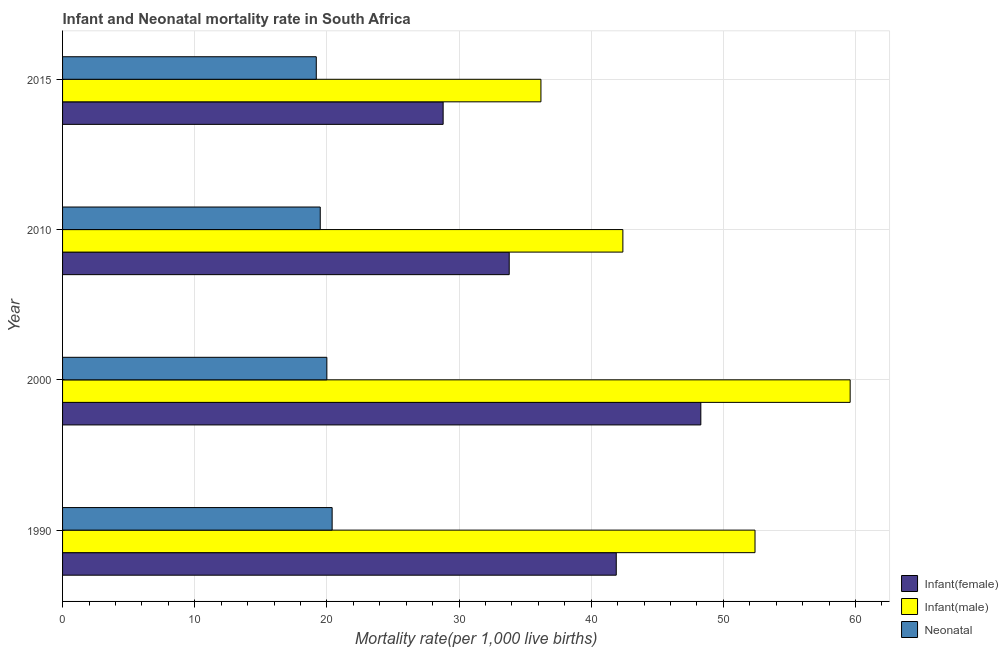How many different coloured bars are there?
Provide a succinct answer. 3. How many groups of bars are there?
Offer a very short reply. 4. Are the number of bars per tick equal to the number of legend labels?
Your answer should be very brief. Yes. How many bars are there on the 1st tick from the bottom?
Offer a very short reply. 3. In how many cases, is the number of bars for a given year not equal to the number of legend labels?
Keep it short and to the point. 0. What is the infant mortality rate(male) in 2015?
Your answer should be very brief. 36.2. Across all years, what is the maximum infant mortality rate(male)?
Offer a terse response. 59.6. Across all years, what is the minimum infant mortality rate(male)?
Offer a terse response. 36.2. In which year was the infant mortality rate(male) maximum?
Offer a very short reply. 2000. In which year was the infant mortality rate(male) minimum?
Your answer should be compact. 2015. What is the total neonatal mortality rate in the graph?
Offer a terse response. 79.1. What is the average infant mortality rate(male) per year?
Make the answer very short. 47.65. In the year 2000, what is the difference between the infant mortality rate(female) and neonatal mortality rate?
Your answer should be very brief. 28.3. In how many years, is the neonatal mortality rate greater than 28 ?
Your response must be concise. 0. What is the ratio of the infant mortality rate(female) in 2000 to that in 2010?
Ensure brevity in your answer.  1.43. What is the difference between the highest and the second highest infant mortality rate(male)?
Provide a short and direct response. 7.2. What is the difference between the highest and the lowest neonatal mortality rate?
Provide a short and direct response. 1.2. In how many years, is the neonatal mortality rate greater than the average neonatal mortality rate taken over all years?
Offer a terse response. 2. What does the 3rd bar from the top in 2015 represents?
Give a very brief answer. Infant(female). What does the 3rd bar from the bottom in 2015 represents?
Provide a short and direct response. Neonatal . How many years are there in the graph?
Your answer should be compact. 4. Are the values on the major ticks of X-axis written in scientific E-notation?
Offer a very short reply. No. Does the graph contain any zero values?
Keep it short and to the point. No. Does the graph contain grids?
Your response must be concise. Yes. Where does the legend appear in the graph?
Make the answer very short. Bottom right. What is the title of the graph?
Ensure brevity in your answer.  Infant and Neonatal mortality rate in South Africa. Does "Tertiary education" appear as one of the legend labels in the graph?
Your answer should be very brief. No. What is the label or title of the X-axis?
Your answer should be very brief. Mortality rate(per 1,0 live births). What is the Mortality rate(per 1,000 live births) in Infant(female) in 1990?
Keep it short and to the point. 41.9. What is the Mortality rate(per 1,000 live births) in Infant(male) in 1990?
Give a very brief answer. 52.4. What is the Mortality rate(per 1,000 live births) in Neonatal  in 1990?
Your answer should be very brief. 20.4. What is the Mortality rate(per 1,000 live births) of Infant(female) in 2000?
Your answer should be compact. 48.3. What is the Mortality rate(per 1,000 live births) of Infant(male) in 2000?
Your response must be concise. 59.6. What is the Mortality rate(per 1,000 live births) of Neonatal  in 2000?
Make the answer very short. 20. What is the Mortality rate(per 1,000 live births) in Infant(female) in 2010?
Provide a succinct answer. 33.8. What is the Mortality rate(per 1,000 live births) of Infant(male) in 2010?
Offer a terse response. 42.4. What is the Mortality rate(per 1,000 live births) of Neonatal  in 2010?
Keep it short and to the point. 19.5. What is the Mortality rate(per 1,000 live births) in Infant(female) in 2015?
Keep it short and to the point. 28.8. What is the Mortality rate(per 1,000 live births) in Infant(male) in 2015?
Keep it short and to the point. 36.2. What is the Mortality rate(per 1,000 live births) of Neonatal  in 2015?
Provide a short and direct response. 19.2. Across all years, what is the maximum Mortality rate(per 1,000 live births) of Infant(female)?
Offer a very short reply. 48.3. Across all years, what is the maximum Mortality rate(per 1,000 live births) of Infant(male)?
Give a very brief answer. 59.6. Across all years, what is the maximum Mortality rate(per 1,000 live births) of Neonatal ?
Your response must be concise. 20.4. Across all years, what is the minimum Mortality rate(per 1,000 live births) of Infant(female)?
Your answer should be very brief. 28.8. Across all years, what is the minimum Mortality rate(per 1,000 live births) in Infant(male)?
Keep it short and to the point. 36.2. What is the total Mortality rate(per 1,000 live births) in Infant(female) in the graph?
Offer a terse response. 152.8. What is the total Mortality rate(per 1,000 live births) in Infant(male) in the graph?
Give a very brief answer. 190.6. What is the total Mortality rate(per 1,000 live births) in Neonatal  in the graph?
Offer a terse response. 79.1. What is the difference between the Mortality rate(per 1,000 live births) of Infant(female) in 1990 and that in 2000?
Your response must be concise. -6.4. What is the difference between the Mortality rate(per 1,000 live births) in Neonatal  in 1990 and that in 2000?
Offer a very short reply. 0.4. What is the difference between the Mortality rate(per 1,000 live births) in Infant(female) in 1990 and that in 2010?
Give a very brief answer. 8.1. What is the difference between the Mortality rate(per 1,000 live births) in Infant(male) in 1990 and that in 2010?
Keep it short and to the point. 10. What is the difference between the Mortality rate(per 1,000 live births) in Neonatal  in 1990 and that in 2010?
Keep it short and to the point. 0.9. What is the difference between the Mortality rate(per 1,000 live births) in Infant(female) in 1990 and that in 2015?
Your answer should be very brief. 13.1. What is the difference between the Mortality rate(per 1,000 live births) of Infant(male) in 2000 and that in 2010?
Your answer should be compact. 17.2. What is the difference between the Mortality rate(per 1,000 live births) of Neonatal  in 2000 and that in 2010?
Your response must be concise. 0.5. What is the difference between the Mortality rate(per 1,000 live births) of Infant(male) in 2000 and that in 2015?
Make the answer very short. 23.4. What is the difference between the Mortality rate(per 1,000 live births) of Infant(female) in 2010 and that in 2015?
Keep it short and to the point. 5. What is the difference between the Mortality rate(per 1,000 live births) in Infant(male) in 2010 and that in 2015?
Ensure brevity in your answer.  6.2. What is the difference between the Mortality rate(per 1,000 live births) of Neonatal  in 2010 and that in 2015?
Keep it short and to the point. 0.3. What is the difference between the Mortality rate(per 1,000 live births) of Infant(female) in 1990 and the Mortality rate(per 1,000 live births) of Infant(male) in 2000?
Make the answer very short. -17.7. What is the difference between the Mortality rate(per 1,000 live births) of Infant(female) in 1990 and the Mortality rate(per 1,000 live births) of Neonatal  in 2000?
Provide a short and direct response. 21.9. What is the difference between the Mortality rate(per 1,000 live births) of Infant(male) in 1990 and the Mortality rate(per 1,000 live births) of Neonatal  in 2000?
Provide a succinct answer. 32.4. What is the difference between the Mortality rate(per 1,000 live births) of Infant(female) in 1990 and the Mortality rate(per 1,000 live births) of Infant(male) in 2010?
Offer a very short reply. -0.5. What is the difference between the Mortality rate(per 1,000 live births) of Infant(female) in 1990 and the Mortality rate(per 1,000 live births) of Neonatal  in 2010?
Keep it short and to the point. 22.4. What is the difference between the Mortality rate(per 1,000 live births) in Infant(male) in 1990 and the Mortality rate(per 1,000 live births) in Neonatal  in 2010?
Your response must be concise. 32.9. What is the difference between the Mortality rate(per 1,000 live births) in Infant(female) in 1990 and the Mortality rate(per 1,000 live births) in Infant(male) in 2015?
Your response must be concise. 5.7. What is the difference between the Mortality rate(per 1,000 live births) in Infant(female) in 1990 and the Mortality rate(per 1,000 live births) in Neonatal  in 2015?
Your answer should be compact. 22.7. What is the difference between the Mortality rate(per 1,000 live births) in Infant(male) in 1990 and the Mortality rate(per 1,000 live births) in Neonatal  in 2015?
Offer a very short reply. 33.2. What is the difference between the Mortality rate(per 1,000 live births) of Infant(female) in 2000 and the Mortality rate(per 1,000 live births) of Infant(male) in 2010?
Your response must be concise. 5.9. What is the difference between the Mortality rate(per 1,000 live births) of Infant(female) in 2000 and the Mortality rate(per 1,000 live births) of Neonatal  in 2010?
Provide a short and direct response. 28.8. What is the difference between the Mortality rate(per 1,000 live births) of Infant(male) in 2000 and the Mortality rate(per 1,000 live births) of Neonatal  in 2010?
Keep it short and to the point. 40.1. What is the difference between the Mortality rate(per 1,000 live births) in Infant(female) in 2000 and the Mortality rate(per 1,000 live births) in Infant(male) in 2015?
Provide a short and direct response. 12.1. What is the difference between the Mortality rate(per 1,000 live births) of Infant(female) in 2000 and the Mortality rate(per 1,000 live births) of Neonatal  in 2015?
Provide a succinct answer. 29.1. What is the difference between the Mortality rate(per 1,000 live births) in Infant(male) in 2000 and the Mortality rate(per 1,000 live births) in Neonatal  in 2015?
Provide a short and direct response. 40.4. What is the difference between the Mortality rate(per 1,000 live births) of Infant(male) in 2010 and the Mortality rate(per 1,000 live births) of Neonatal  in 2015?
Offer a terse response. 23.2. What is the average Mortality rate(per 1,000 live births) of Infant(female) per year?
Offer a very short reply. 38.2. What is the average Mortality rate(per 1,000 live births) in Infant(male) per year?
Provide a succinct answer. 47.65. What is the average Mortality rate(per 1,000 live births) of Neonatal  per year?
Your answer should be very brief. 19.77. In the year 2000, what is the difference between the Mortality rate(per 1,000 live births) in Infant(female) and Mortality rate(per 1,000 live births) in Infant(male)?
Your response must be concise. -11.3. In the year 2000, what is the difference between the Mortality rate(per 1,000 live births) of Infant(female) and Mortality rate(per 1,000 live births) of Neonatal ?
Your answer should be very brief. 28.3. In the year 2000, what is the difference between the Mortality rate(per 1,000 live births) of Infant(male) and Mortality rate(per 1,000 live births) of Neonatal ?
Give a very brief answer. 39.6. In the year 2010, what is the difference between the Mortality rate(per 1,000 live births) of Infant(female) and Mortality rate(per 1,000 live births) of Infant(male)?
Your response must be concise. -8.6. In the year 2010, what is the difference between the Mortality rate(per 1,000 live births) of Infant(female) and Mortality rate(per 1,000 live births) of Neonatal ?
Keep it short and to the point. 14.3. In the year 2010, what is the difference between the Mortality rate(per 1,000 live births) of Infant(male) and Mortality rate(per 1,000 live births) of Neonatal ?
Provide a short and direct response. 22.9. In the year 2015, what is the difference between the Mortality rate(per 1,000 live births) of Infant(female) and Mortality rate(per 1,000 live births) of Infant(male)?
Make the answer very short. -7.4. In the year 2015, what is the difference between the Mortality rate(per 1,000 live births) of Infant(male) and Mortality rate(per 1,000 live births) of Neonatal ?
Offer a very short reply. 17. What is the ratio of the Mortality rate(per 1,000 live births) of Infant(female) in 1990 to that in 2000?
Your response must be concise. 0.87. What is the ratio of the Mortality rate(per 1,000 live births) in Infant(male) in 1990 to that in 2000?
Provide a short and direct response. 0.88. What is the ratio of the Mortality rate(per 1,000 live births) of Infant(female) in 1990 to that in 2010?
Make the answer very short. 1.24. What is the ratio of the Mortality rate(per 1,000 live births) in Infant(male) in 1990 to that in 2010?
Provide a short and direct response. 1.24. What is the ratio of the Mortality rate(per 1,000 live births) in Neonatal  in 1990 to that in 2010?
Keep it short and to the point. 1.05. What is the ratio of the Mortality rate(per 1,000 live births) of Infant(female) in 1990 to that in 2015?
Make the answer very short. 1.45. What is the ratio of the Mortality rate(per 1,000 live births) in Infant(male) in 1990 to that in 2015?
Provide a short and direct response. 1.45. What is the ratio of the Mortality rate(per 1,000 live births) in Neonatal  in 1990 to that in 2015?
Your answer should be very brief. 1.06. What is the ratio of the Mortality rate(per 1,000 live births) in Infant(female) in 2000 to that in 2010?
Make the answer very short. 1.43. What is the ratio of the Mortality rate(per 1,000 live births) in Infant(male) in 2000 to that in 2010?
Make the answer very short. 1.41. What is the ratio of the Mortality rate(per 1,000 live births) in Neonatal  in 2000 to that in 2010?
Make the answer very short. 1.03. What is the ratio of the Mortality rate(per 1,000 live births) in Infant(female) in 2000 to that in 2015?
Provide a short and direct response. 1.68. What is the ratio of the Mortality rate(per 1,000 live births) in Infant(male) in 2000 to that in 2015?
Make the answer very short. 1.65. What is the ratio of the Mortality rate(per 1,000 live births) in Neonatal  in 2000 to that in 2015?
Your response must be concise. 1.04. What is the ratio of the Mortality rate(per 1,000 live births) in Infant(female) in 2010 to that in 2015?
Offer a very short reply. 1.17. What is the ratio of the Mortality rate(per 1,000 live births) of Infant(male) in 2010 to that in 2015?
Offer a terse response. 1.17. What is the ratio of the Mortality rate(per 1,000 live births) in Neonatal  in 2010 to that in 2015?
Your response must be concise. 1.02. What is the difference between the highest and the second highest Mortality rate(per 1,000 live births) of Neonatal ?
Offer a very short reply. 0.4. What is the difference between the highest and the lowest Mortality rate(per 1,000 live births) in Infant(male)?
Ensure brevity in your answer.  23.4. What is the difference between the highest and the lowest Mortality rate(per 1,000 live births) in Neonatal ?
Provide a succinct answer. 1.2. 